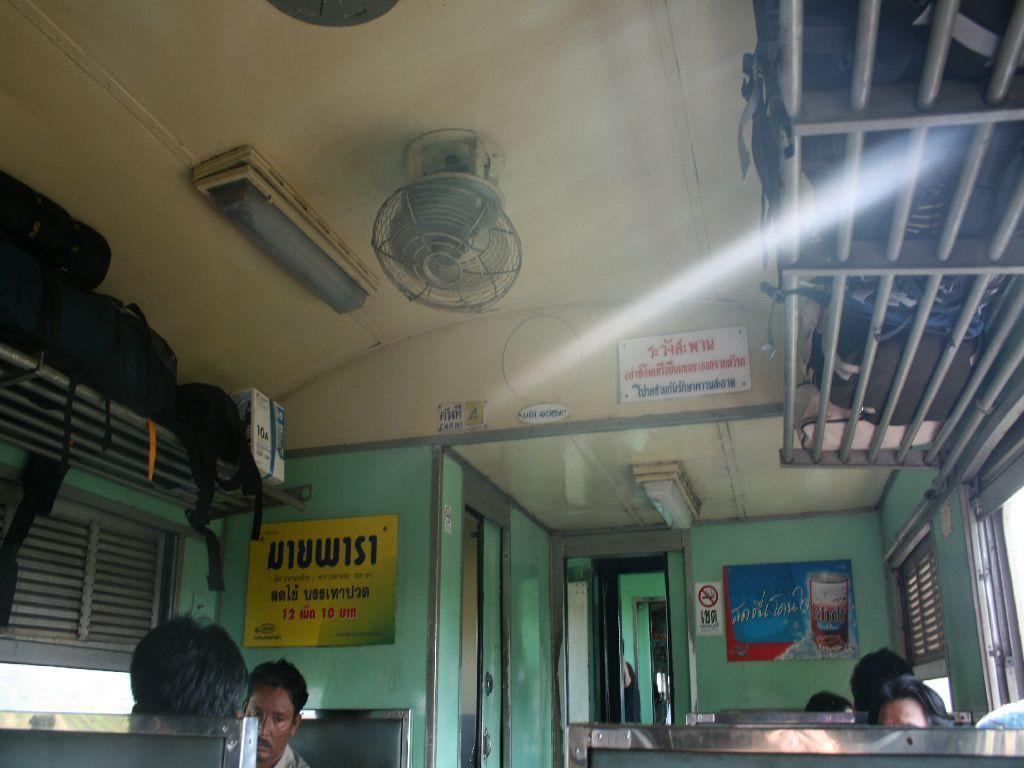In one or two sentences, can you explain what this image depicts? In this image we can see few people travelling in the train. There are many objects placed on the rack. There are few advertising boards in the image. There are few lights and fans in the image. 